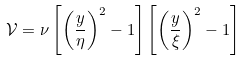Convert formula to latex. <formula><loc_0><loc_0><loc_500><loc_500>\mathcal { V } = \nu \left [ \left ( \frac { y } { \eta } \right ) ^ { 2 } - 1 \right ] \left [ \left ( \frac { y } { \xi } \right ) ^ { 2 } - 1 \right ]</formula> 